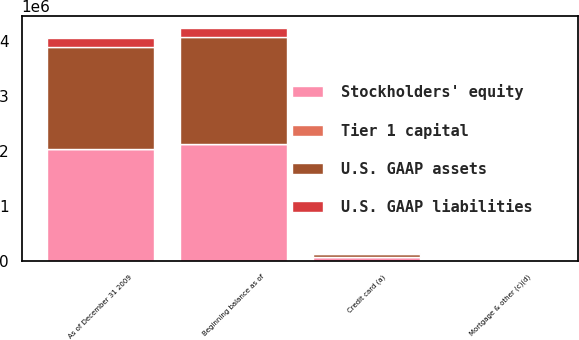Convert chart. <chart><loc_0><loc_0><loc_500><loc_500><stacked_bar_chart><ecel><fcel>As of December 31 2009<fcel>Credit card (a)<fcel>Mortgage & other (c)(d)<fcel>Beginning balance as of<nl><fcel>Stockholders' equity<fcel>2.03199e+06<fcel>60901<fcel>9059<fcel>2.11967e+06<nl><fcel>U.S. GAAP assets<fcel>1.86662e+06<fcel>65353<fcel>9107<fcel>1.95883e+06<nl><fcel>U.S. GAAP liabilities<fcel>165365<fcel>4452<fcel>48<fcel>160845<nl><fcel>Tier 1 capital<fcel>11.1<fcel>0.3<fcel>0.04<fcel>10.76<nl></chart> 